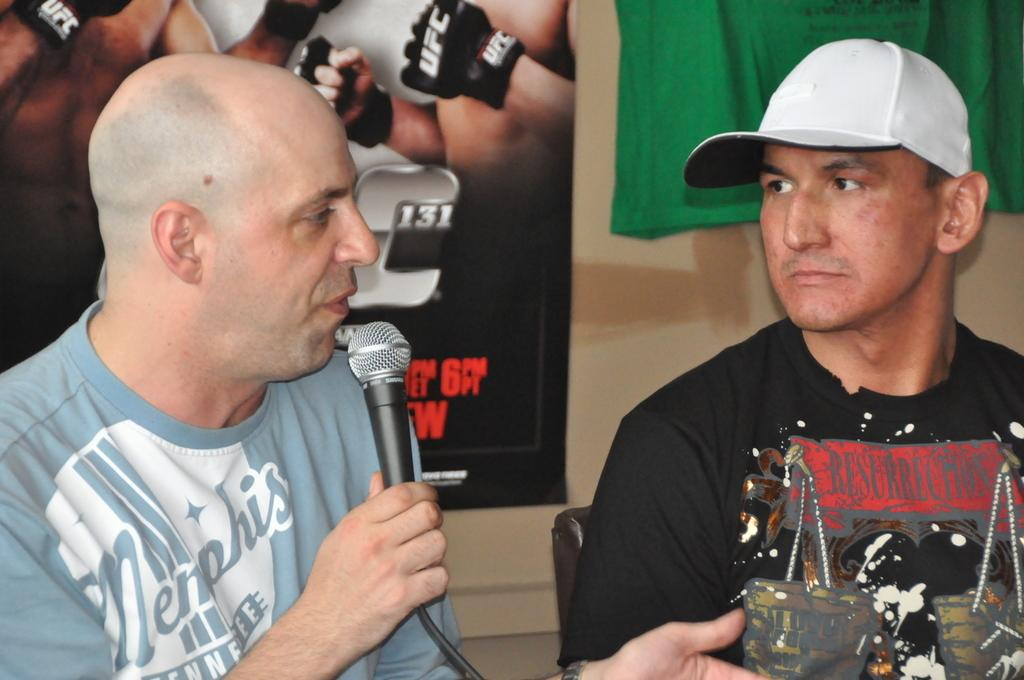How many people are in the image? There are two persons in the image. What are the persons doing in the image? The persons are sitting on chairs and holding microphones. What activity are the persons engaged in? The persons are speaking. What can be seen in the background of the image? There is a wall in the background of the image. Can you hear the tiger whistling in the image? There is no tiger or whistling present in the image. 